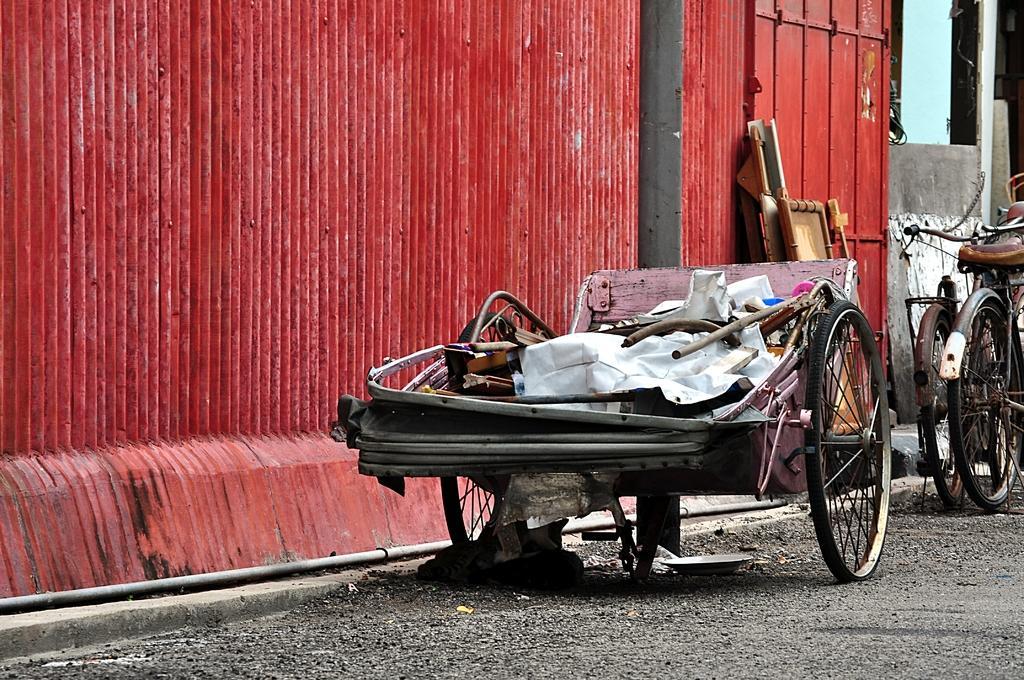How would you summarize this image in a sentence or two? In this image we can see a cart and two bicycles on the surface of the road, behind them there is a metal wall. 